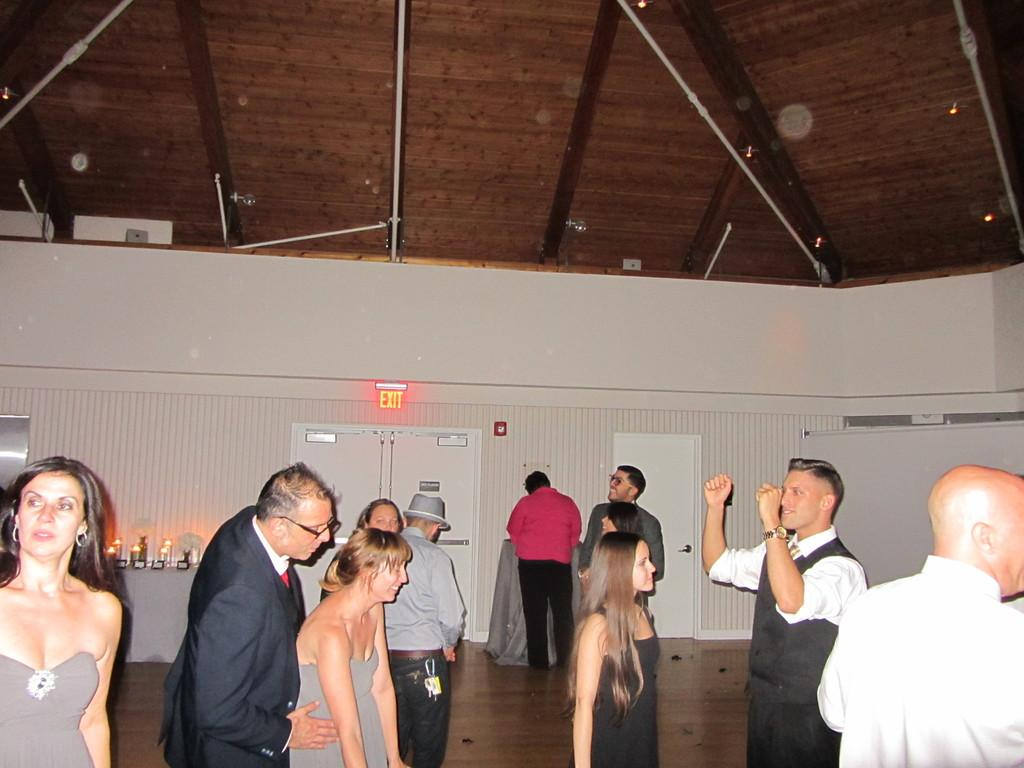What type of surface are the people standing on in the image? The people are standing on a wooden floor. What can be seen in the background of the image? There is a wall in the background. What feature is present on the wall? The wall has doors at the top. What part of a building is visible in the image? The roof is visible in the image. What type of representative is standing next to the door in the image? There is no representative present in the image; it only shows people standing on a wooden floor with a wall and doors in the background. 